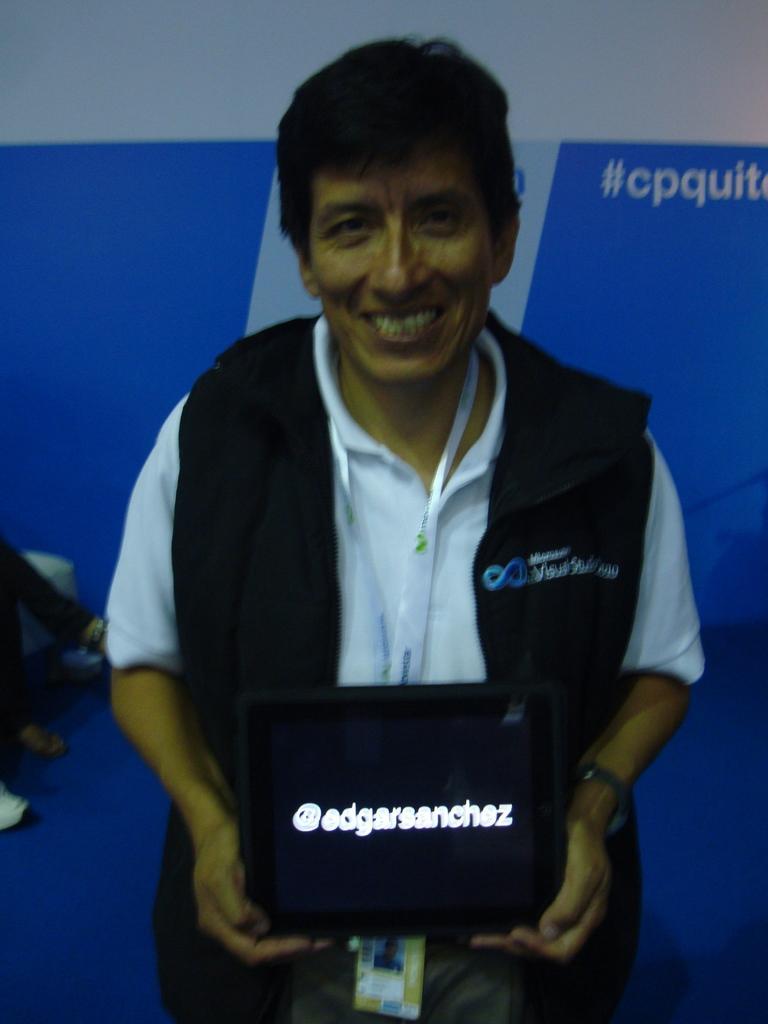How would you summarize this image in a sentence or two? This is the man standing and smiling. He is holding a tablet with a display. In the background, I think this is a hoarding. On the left side of the image, I can see a person's legs. 